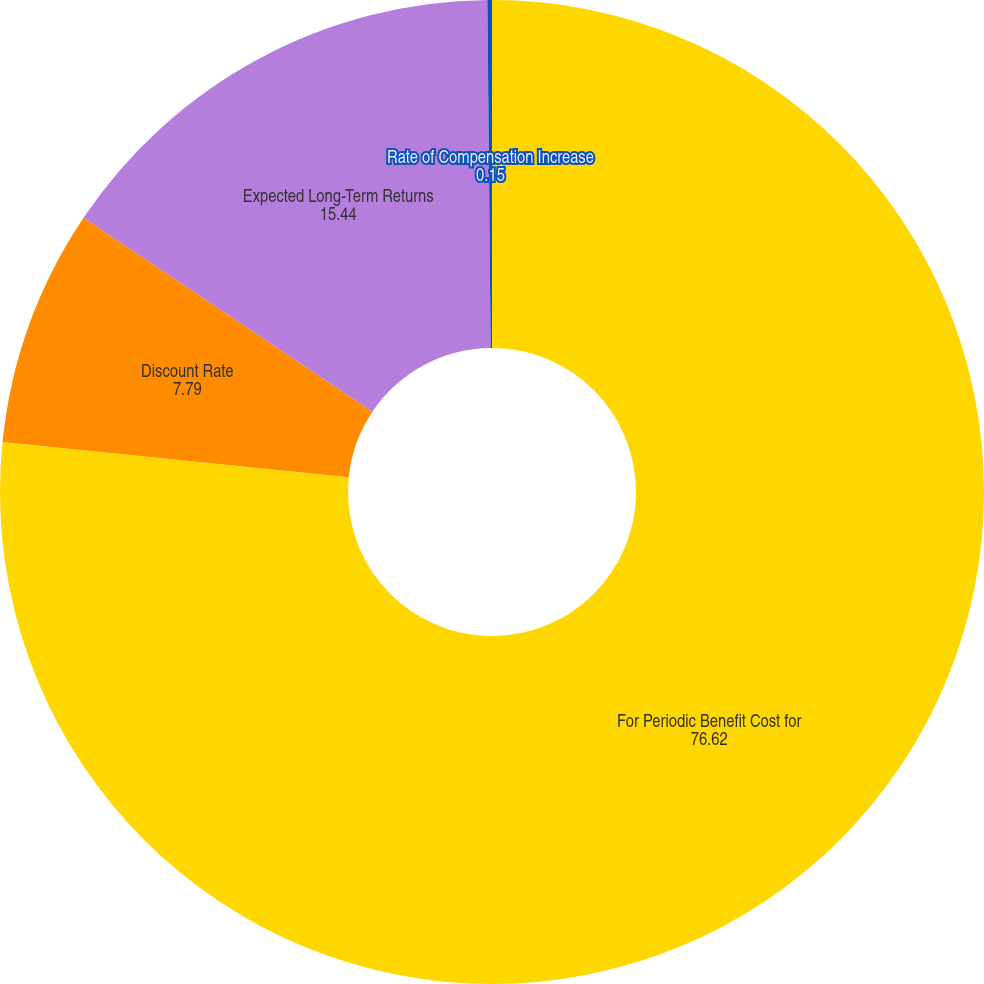Convert chart. <chart><loc_0><loc_0><loc_500><loc_500><pie_chart><fcel>For Periodic Benefit Cost for<fcel>Discount Rate<fcel>Expected Long-Term Returns<fcel>Rate of Compensation Increase<nl><fcel>76.62%<fcel>7.79%<fcel>15.44%<fcel>0.15%<nl></chart> 